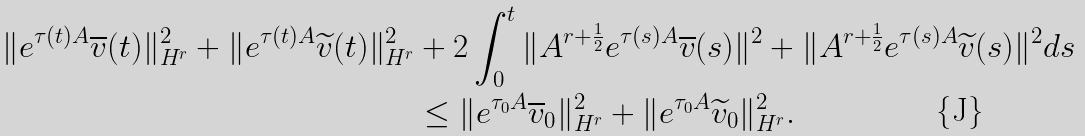<formula> <loc_0><loc_0><loc_500><loc_500>\| e ^ { \tau ( t ) A } \overline { v } ( t ) \| _ { H ^ { r } } ^ { 2 } + \| e ^ { \tau ( t ) A } \widetilde { v } ( t ) \| _ { H ^ { r } } ^ { 2 } & + 2 \int _ { 0 } ^ { t } \| A ^ { r + \frac { 1 } { 2 } } e ^ { \tau ( s ) A } \overline { v } ( s ) \| ^ { 2 } + \| A ^ { r + \frac { 1 } { 2 } } e ^ { \tau ( s ) A } \widetilde { v } ( s ) \| ^ { 2 } d s \\ & \leq \| e ^ { \tau _ { 0 } A } \overline { v } _ { 0 } \| _ { H ^ { r } } ^ { 2 } + \| e ^ { \tau _ { 0 } A } \widetilde { v } _ { 0 } \| _ { H ^ { r } } ^ { 2 } .</formula> 